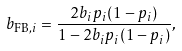<formula> <loc_0><loc_0><loc_500><loc_500>b _ { \text {FB} , i } = \frac { 2 b _ { i } p _ { i } ( 1 - p _ { i } ) } { 1 - 2 b _ { i } p _ { i } ( 1 - p _ { i } ) } ,</formula> 